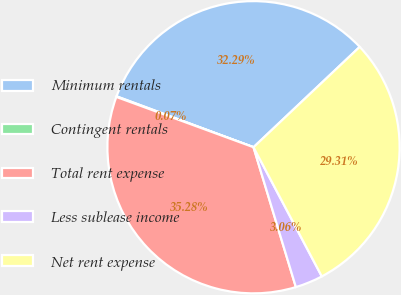<chart> <loc_0><loc_0><loc_500><loc_500><pie_chart><fcel>Minimum rentals<fcel>Contingent rentals<fcel>Total rent expense<fcel>Less sublease income<fcel>Net rent expense<nl><fcel>32.29%<fcel>0.07%<fcel>35.28%<fcel>3.06%<fcel>29.31%<nl></chart> 